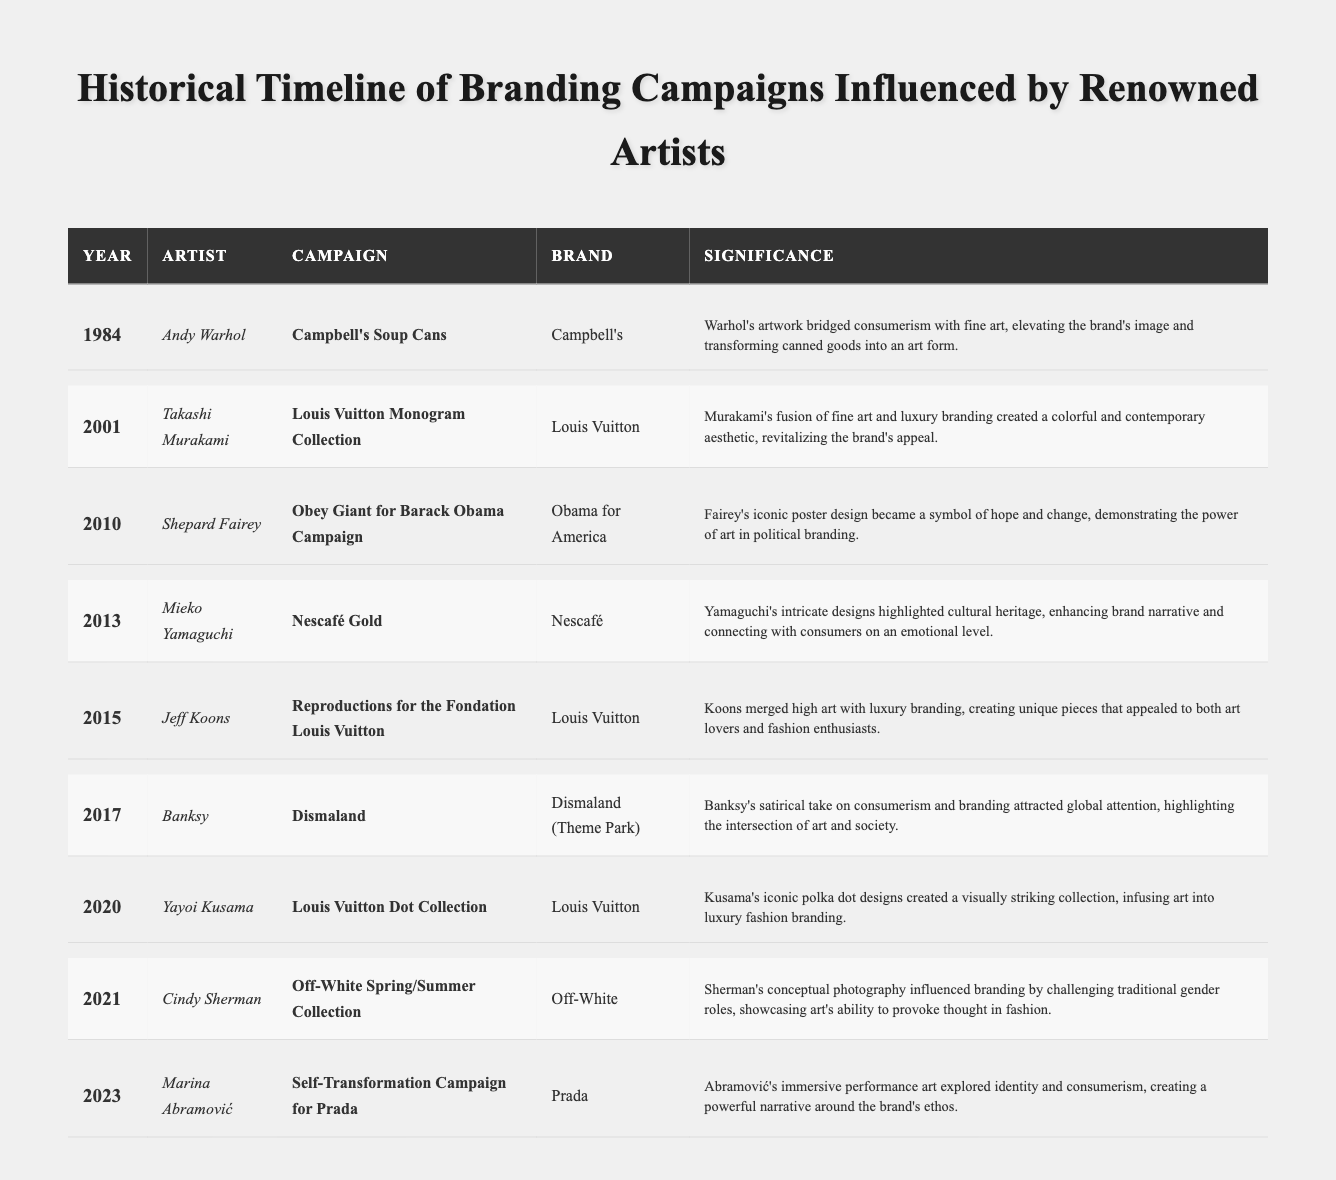What is the significance of Andy Warhol's campaign for Campbell's? The table states that Warhol's artwork transformed canned goods into an art form and elevated the brand's image by bridging consumerism with fine art.
Answer: Warhol's campaign elevated the brand's image and transformed canned goods into art How many campaigns did Louis Vuitton appear in, according to the table? Louis Vuitton appears in three campaigns: the Monogram Collection by Murakami (2001), Reproductions by Koons (2015), and the Dot Collection by Kusama (2020).
Answer: Three campaigns Which artist's campaign is related to political branding, and what is the name of that campaign? Shepard Fairey's campaign for Obama, titled "Obey Giant for Barack Obama Campaign," is related to political branding.
Answer: Shepard Fairey, "Obey Giant for Barack Obama Campaign" True or False: Mieko Yamaguchi's campaign for Nescafé Gold emphasizes modernity in brand narrative. The significance states that Yamaguchi's designs highlight cultural heritage, not modernity, hence the statement is false.
Answer: False What is the difference in years between the first and the last listed campaigns in the table? The first campaign is from 1984 and the last from 2023. The difference in years is 2023 - 1984 = 39 years.
Answer: 39 years Which artist had a campaign that intersected art with a critique of consumerism, and what was this critique? Banksy's campaign "Dismaland" is noted for its satirical take on consumerism and branding, attracting global attention.
Answer: Banksy, critique of consumerism Identify the brand associated with the significance of "creating a powerful narrative around identity and consumerism." The brand associated with this significance is Prada, linked to Marina Abramović's campaign in 2023.
Answer: Prada Which campaign is described as revitalizing a luxury brand's appeal, and who was the artist? The "Louis Vuitton Monogram Collection" campaign revitalized the brand's appeal, created by artist Takashi Murakami.
Answer: Louis Vuitton Monogram Collection, Takashi Murakami What immediate effect did Jeff Koons’ campaign have on targeting art lovers and fashion enthusiasts? Koons' campaign merged high art with luxury branding, creating unique pieces that appealed to both groups primarily.
Answer: It created unique pieces appealing to both groups In how many campaigns did Banksy participate, and what was the main theme of his campaign? Banksy participated in one campaign, "Dismaland," which focused on consumerism and branding as its main theme.
Answer: One campaign, focusing on consumerism 